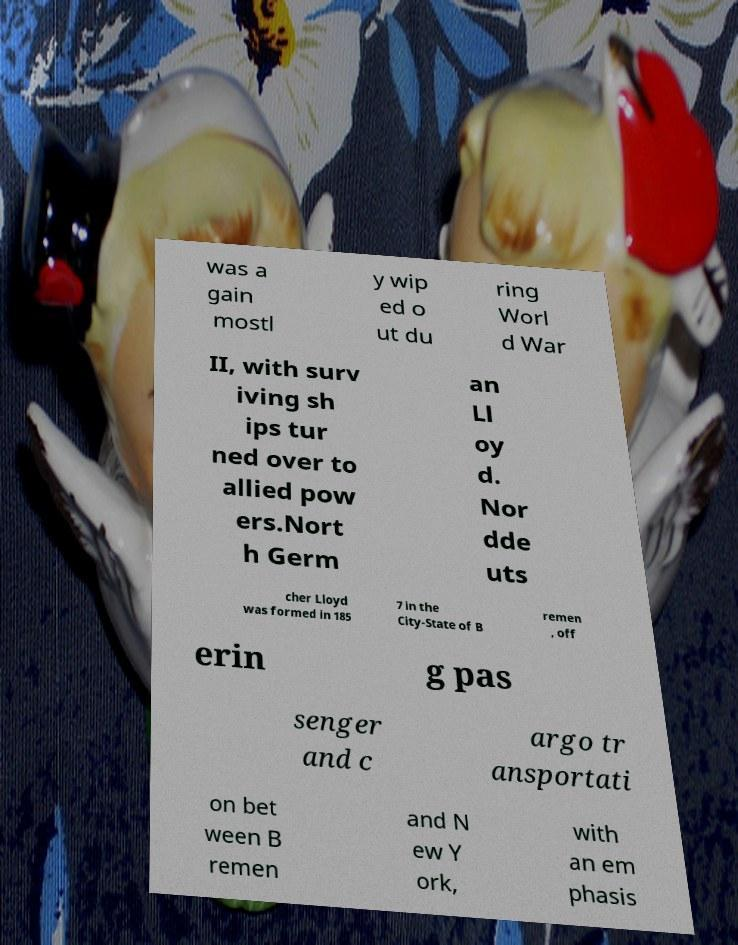Could you extract and type out the text from this image? was a gain mostl y wip ed o ut du ring Worl d War II, with surv iving sh ips tur ned over to allied pow ers.Nort h Germ an Ll oy d. Nor dde uts cher Lloyd was formed in 185 7 in the City-State of B remen , off erin g pas senger and c argo tr ansportati on bet ween B remen and N ew Y ork, with an em phasis 